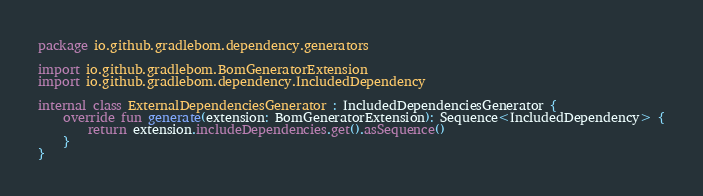<code> <loc_0><loc_0><loc_500><loc_500><_Kotlin_>package io.github.gradlebom.dependency.generators

import io.github.gradlebom.BomGeneratorExtension
import io.github.gradlebom.dependency.IncludedDependency

internal class ExternalDependenciesGenerator : IncludedDependenciesGenerator {
    override fun generate(extension: BomGeneratorExtension): Sequence<IncludedDependency> {
        return extension.includeDependencies.get().asSequence()
    }
}
</code> 